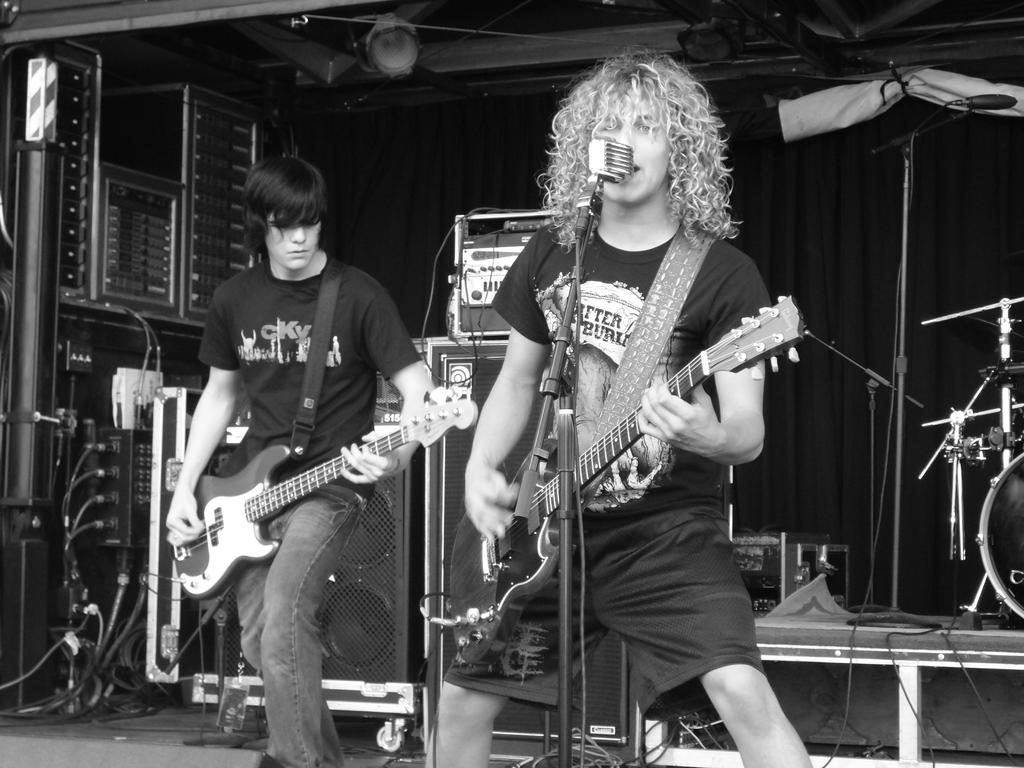How many people are in the image? There are two persons standing in the image. What are the two persons holding? The two persons are holding guitars. What is one person doing in the image? One person is singing. What can be seen near the person who is singing? There is a microphone with a stand in the image. What is visible in the background of the image? There is a curtain and musical instruments in the background of the image. How many houses can be seen in the image? There are no houses visible in the image. What type of mouth is present on the guitar in the image? There is no mouth present on the guitar in the image; guitars do not have mouths. 